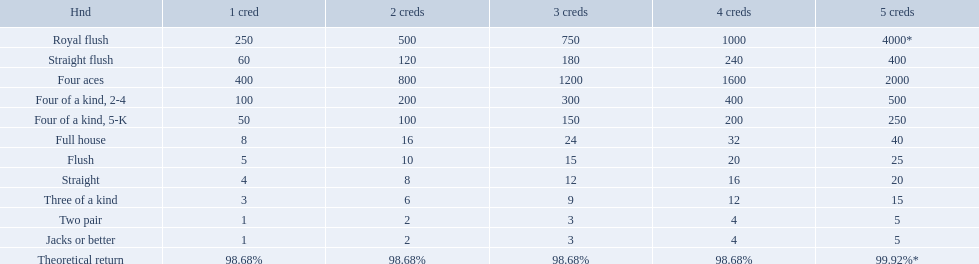Which hand is the third best hand in the card game super aces? Four aces. Which hand is the second best hand? Straight flush. Which hand had is the best hand? Royal flush. What is the values in the 5 credits area? 4000*, 400, 2000, 500, 250, 40, 25, 20, 15, 5, 5. Which of these is for a four of a kind? 500, 250. What is the higher value? 500. What hand is this for Four of a kind, 2-4. Which hand is lower than straight flush? Four aces. Which hand is lower than four aces? Four of a kind, 2-4. Which hand is higher out of straight and flush? Flush. What are each of the hands? Royal flush, Straight flush, Four aces, Four of a kind, 2-4, Four of a kind, 5-K, Full house, Flush, Straight, Three of a kind, Two pair, Jacks or better, Theoretical return. Which hand ranks higher between straights and flushes? Flush. 